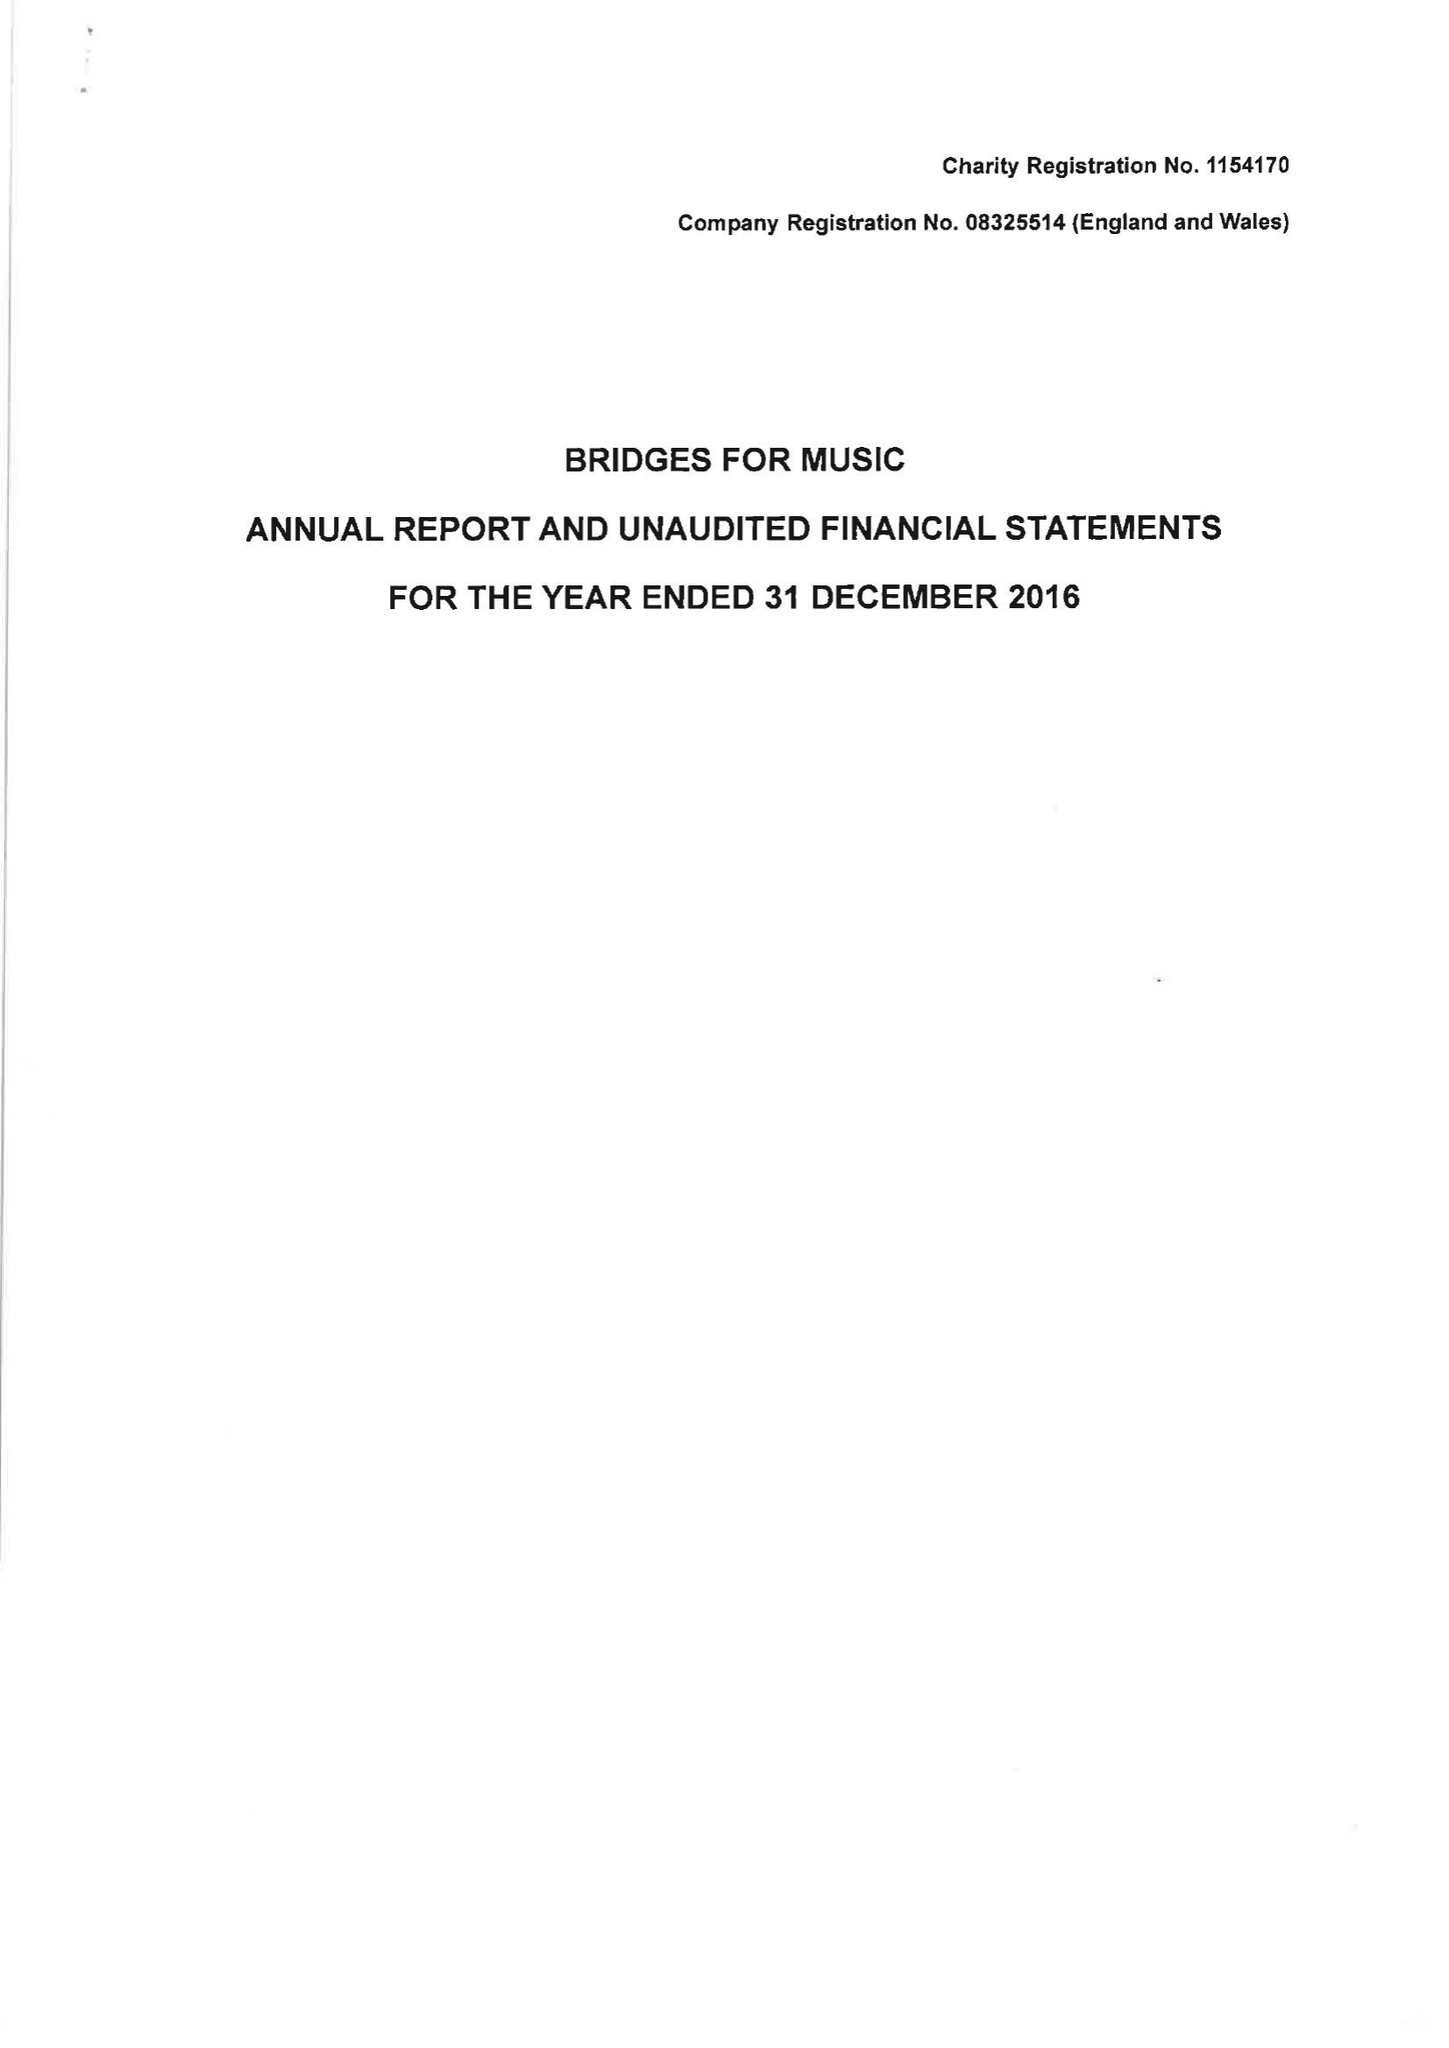What is the value for the charity_number?
Answer the question using a single word or phrase. 1154170 